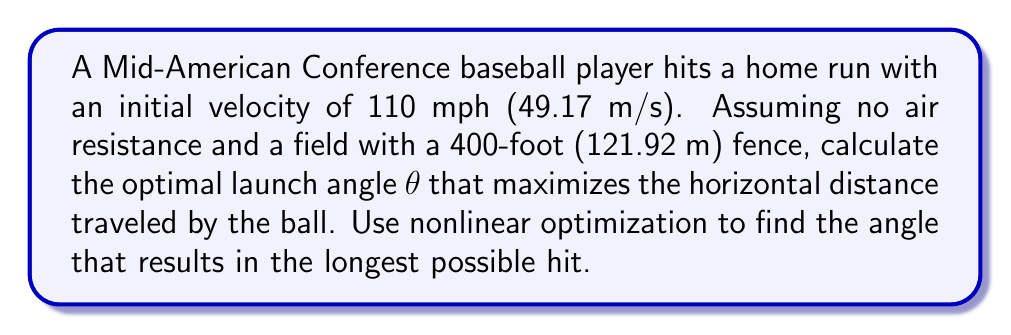Help me with this question. To solve this problem, we'll use the projectile motion equations and nonlinear optimization:

1) The horizontal distance (x) traveled by a projectile is given by:
   $$x = \frac{v_0^2 \sin(2\theta)}{g}$$
   where $v_0$ is the initial velocity, θ is the launch angle, and g is the acceleration due to gravity (9.81 m/s²).

2) Our objective is to maximize x with respect to θ. This is a nonlinear optimization problem.

3) To find the maximum, we differentiate x with respect to θ and set it to zero:
   $$\frac{dx}{d\theta} = \frac{2v_0^2 \cos(2\theta)}{g} = 0$$

4) Solving this equation:
   $\cos(2\theta) = 0$
   $2\theta = \frac{\pi}{2}$
   $\theta = \frac{\pi}{4} = 45°$

5) The second derivative is negative at this point, confirming it's a maximum.

6) To verify this is sufficient for clearing the fence:
   $$x = \frac{(49.17 \text{ m/s})^2 \sin(2 \cdot 45°)}{9.81 \text{ m/s}^2} = 246.7 \text{ m}$$

   246.7 m is greater than 121.92 m, so this angle clears the fence.

Therefore, the optimal launch angle for maximizing the horizontal distance, and consequently hitting a home run over the 400-foot fence, is 45°.
Answer: 45° 